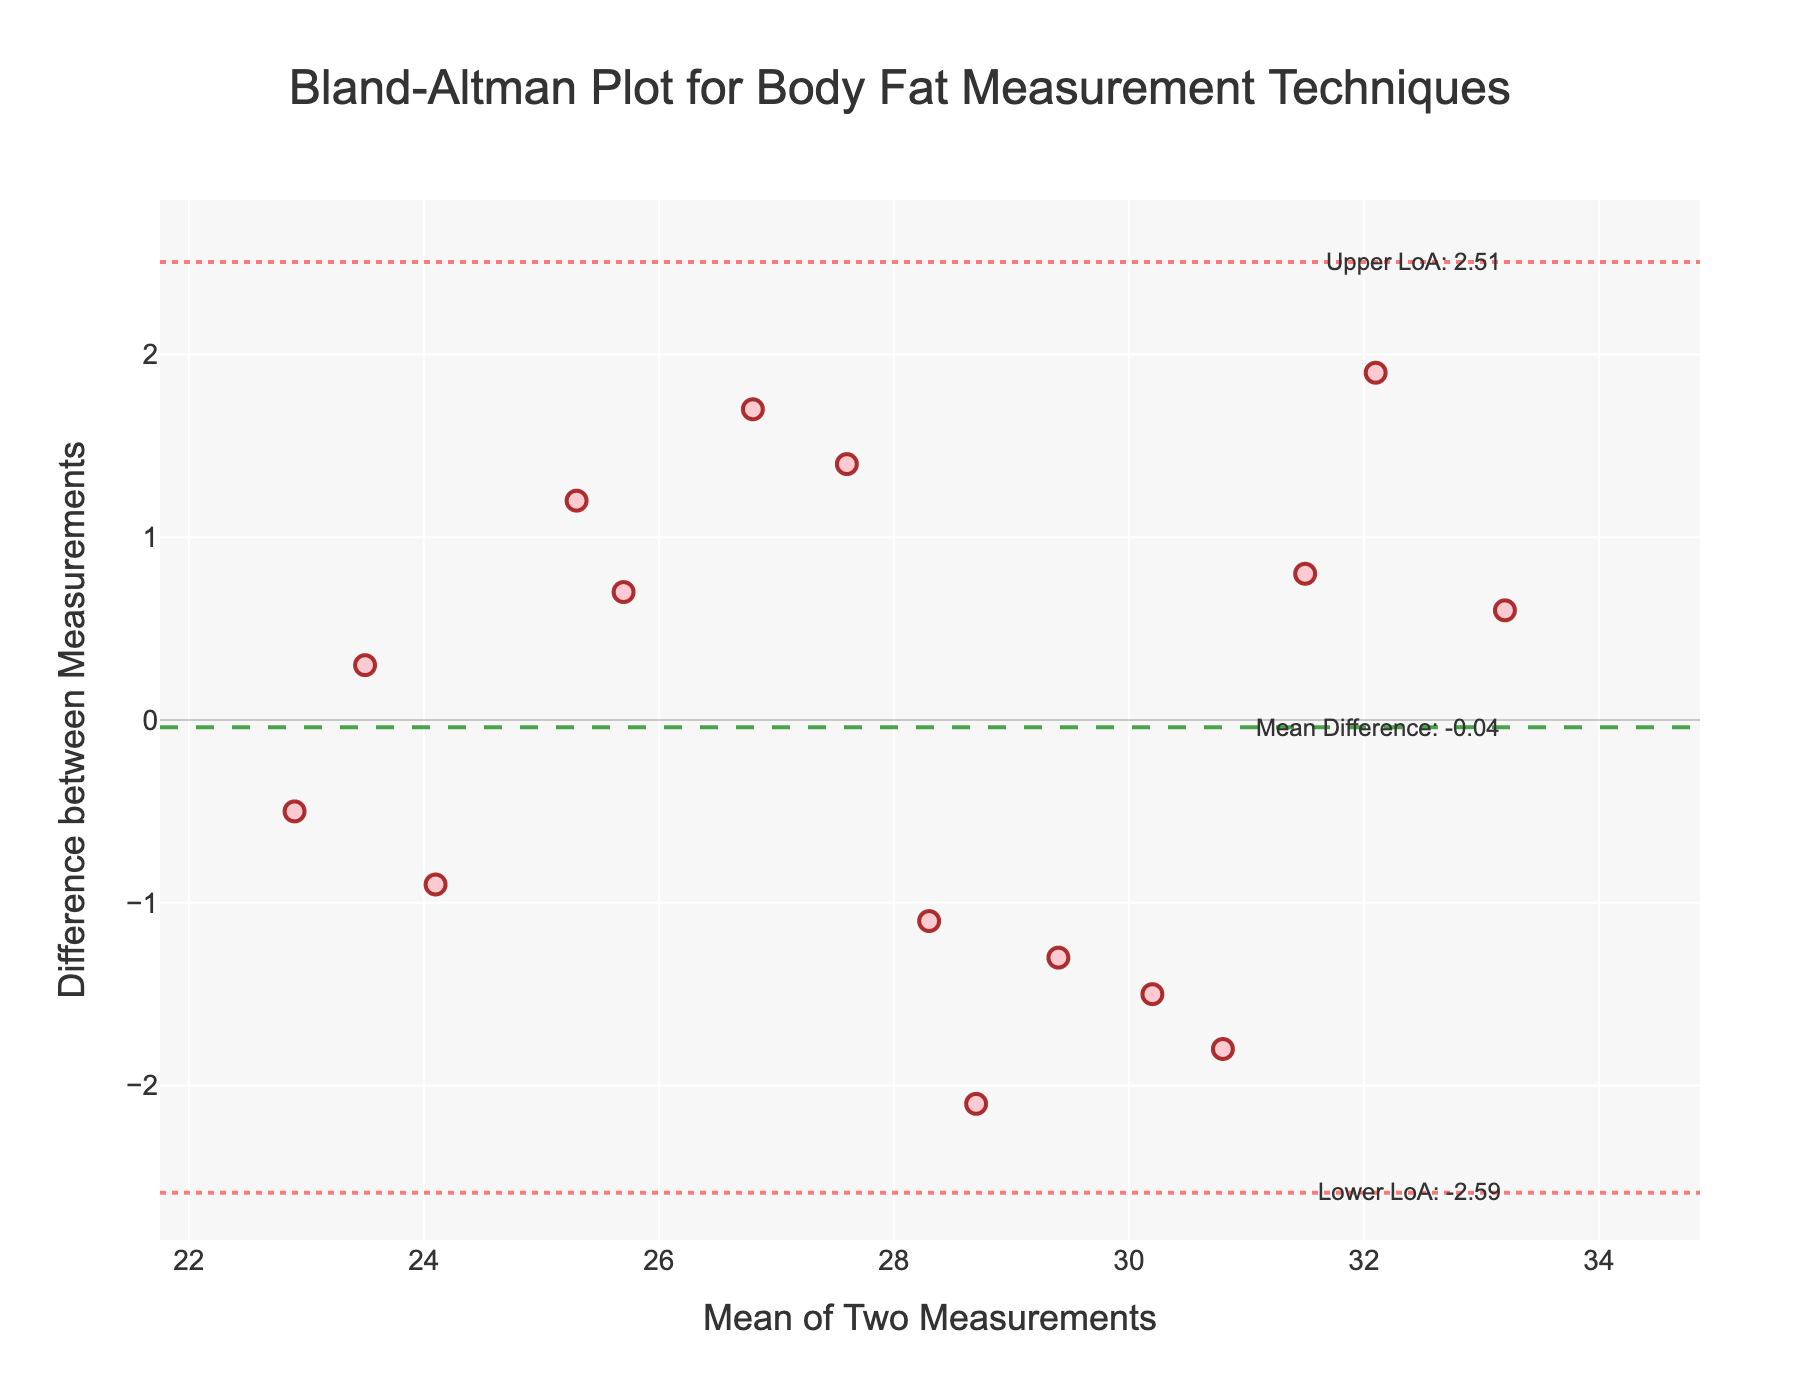What is the title of the plot? The title is displayed at the top-center of the plot, which reads 'Bland-Altman Plot for Body Fat Measurement Techniques'.
Answer: Bland-Altman Plot for Body Fat Measurement Techniques How many measurements are compared in the plot? We count the number of individual markers (data points) on the Bland-Altman plot. There are 14 data points visible on the plot.
Answer: 14 What is the mean difference between the measurements? The mean difference is indicated by the horizontal dashed line, with an annotation that reads 'Mean Difference: 0.27'.
Answer: 0.27 What are the upper and lower limits of agreement (LoA)? The upper and lower limits of agreement are indicated by dotted lines and annotations on the plot. The upper LoA is labeled 'Upper LoA: 1.94', and the lower LoA is labeled 'Lower LoA: -1.41'.
Answer: Upper LoA: 1.94, Lower LoA: -1.41 What is the maximum mean value among the measurement pairs? The maximum mean value can be identified from the x-axis where the data points are plotted. The highest x-axis value for the mean of the two measurements is 33.2.
Answer: 33.2 How many data points lie above the mean difference line? By visually inspecting the plot, we count the number of data points that are above the horizontal dashed mean difference line. There are 8 data points above the mean difference line.
Answer: 8 Which pair of measurements has the largest negative difference? The largest negative difference is indicated by the lowest y-axis point. The data point at the lowest y-value (-2.1) corresponds to the BIA and Hydrostatic pair.
Answer: BIA and Hydrostatic Is there any pair of measurements that falls exactly on the upper limit of agreement? We observe the data points on the plot to see if any falls precisely on the upper line. None of the data points fall exactly on the upper limit of agreement, which is y = 1.94.
Answer: No What measurement pair has the smallest mean value among the pairs? The leftmost data point on the x-axis corresponds to the smallest mean value. This data point at 22.9 corresponds to the MRI and CT Scan pair.
Answer: MRI and CT Scan Which pair of measurements has the largest positive difference? The largest positive difference is indicated by the highest y-axis point. The data point at the highest y-value (1.9) corresponds to the MRI and BIA pair.
Answer: MRI and BIA 